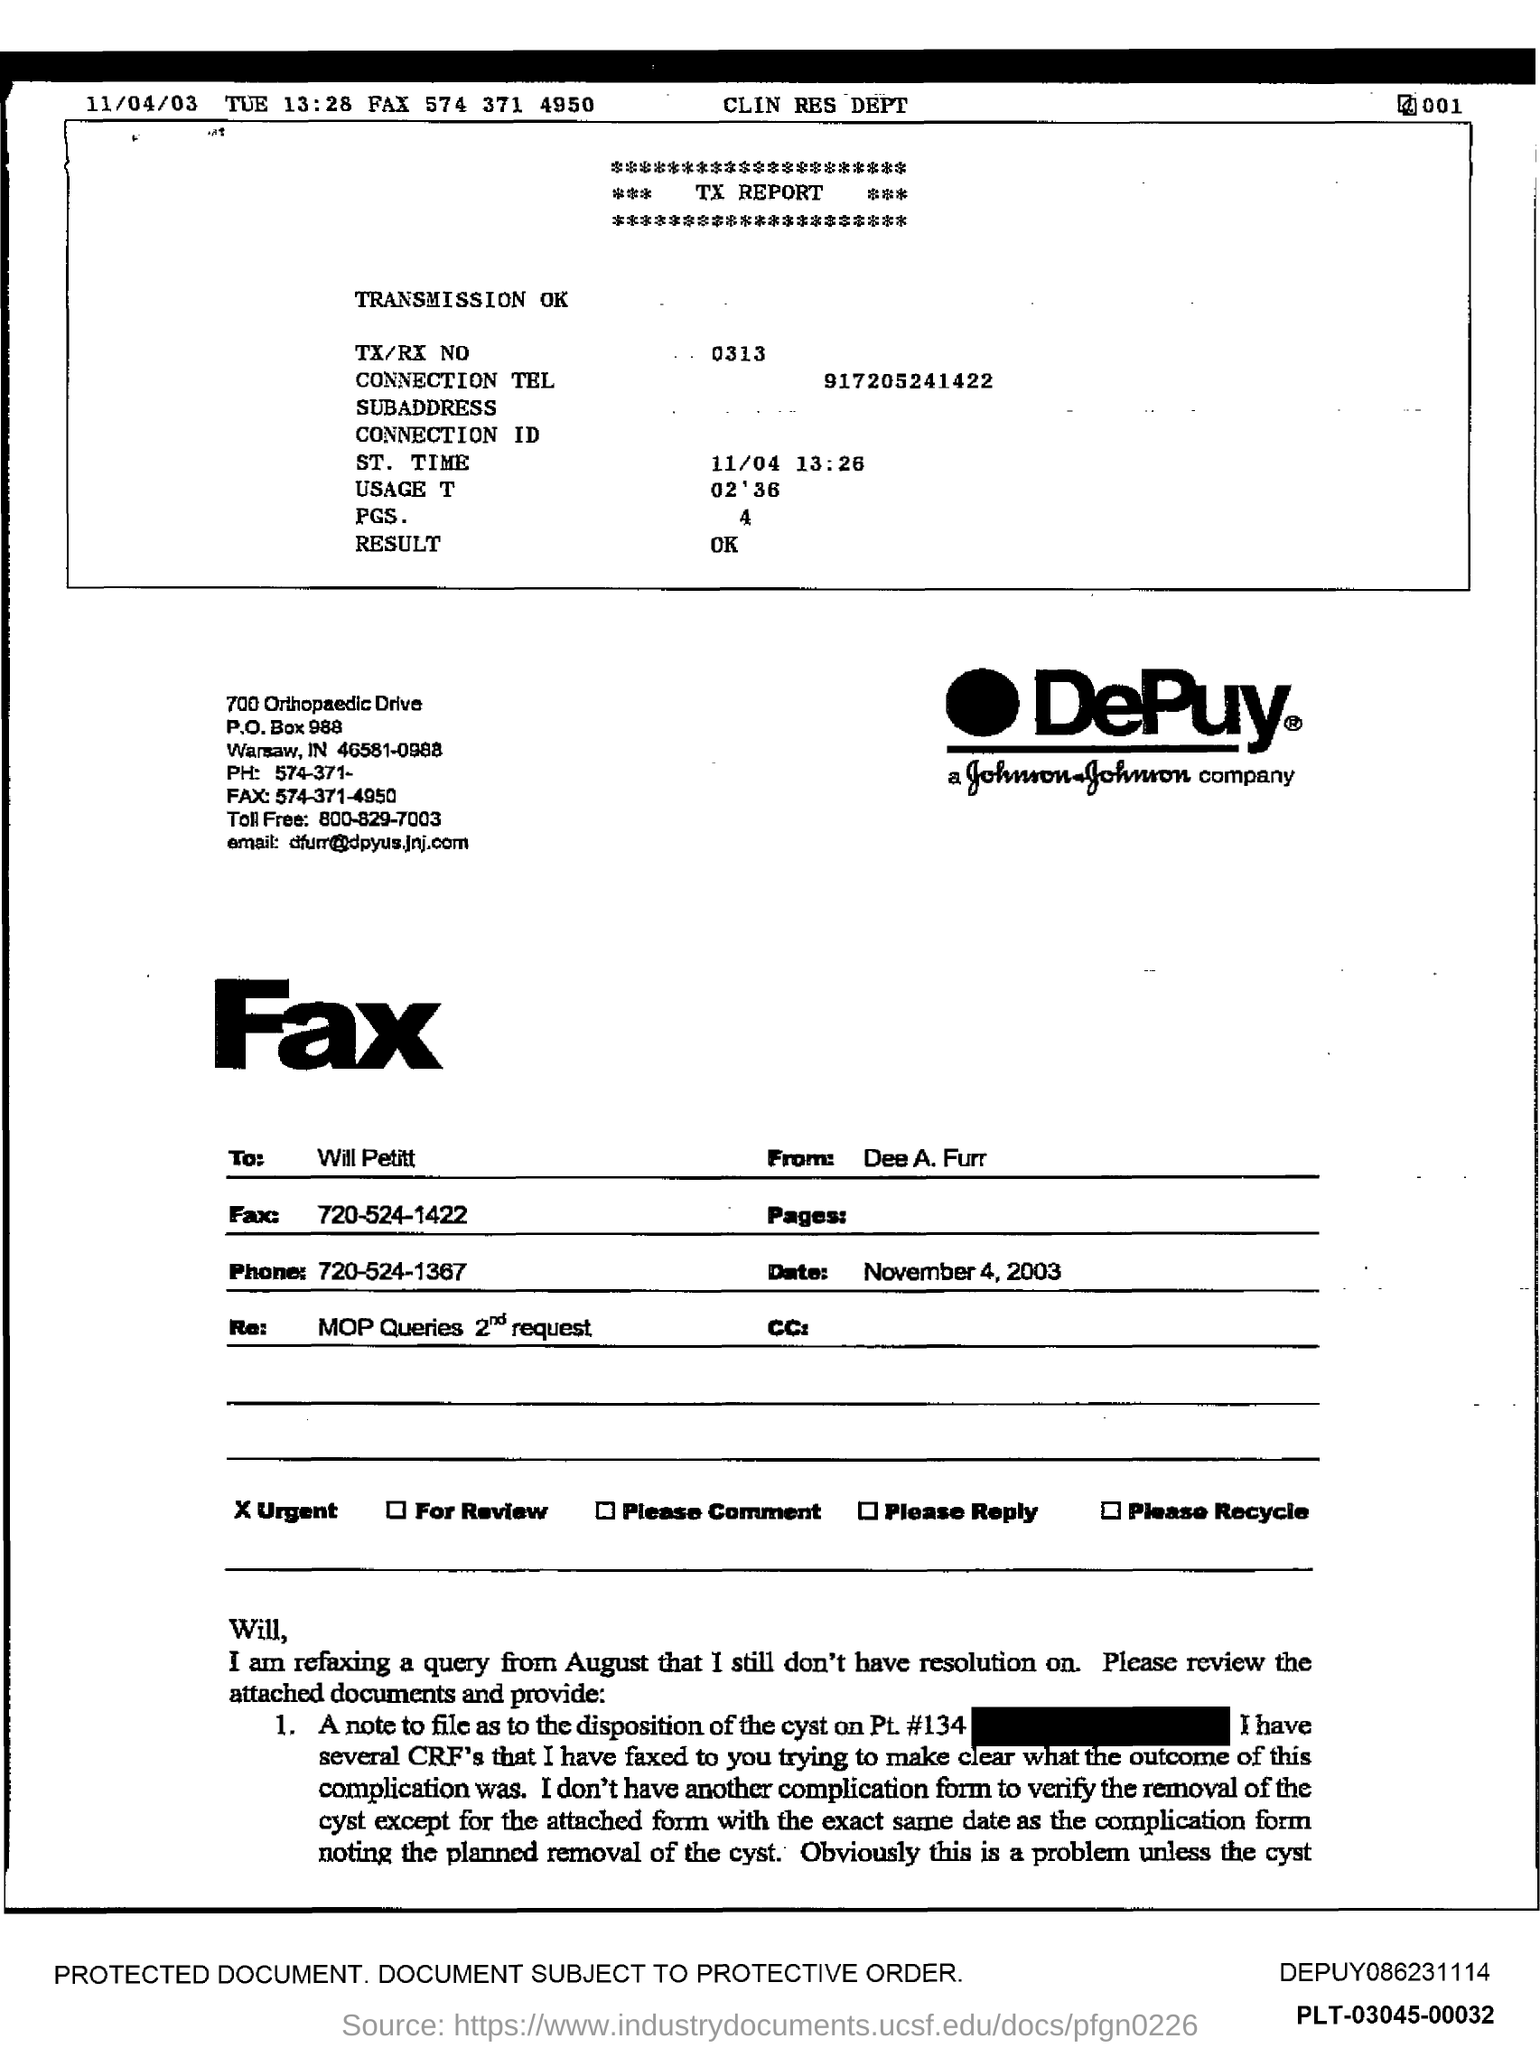What is the date given on the left?
 11/04/03 